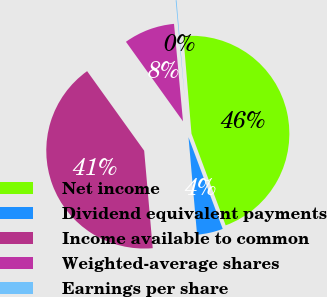Convert chart to OTSL. <chart><loc_0><loc_0><loc_500><loc_500><pie_chart><fcel>Net income<fcel>Dividend equivalent payments<fcel>Income available to common<fcel>Weighted-average shares<fcel>Earnings per share<nl><fcel>45.64%<fcel>4.29%<fcel>41.49%<fcel>8.44%<fcel>0.14%<nl></chart> 